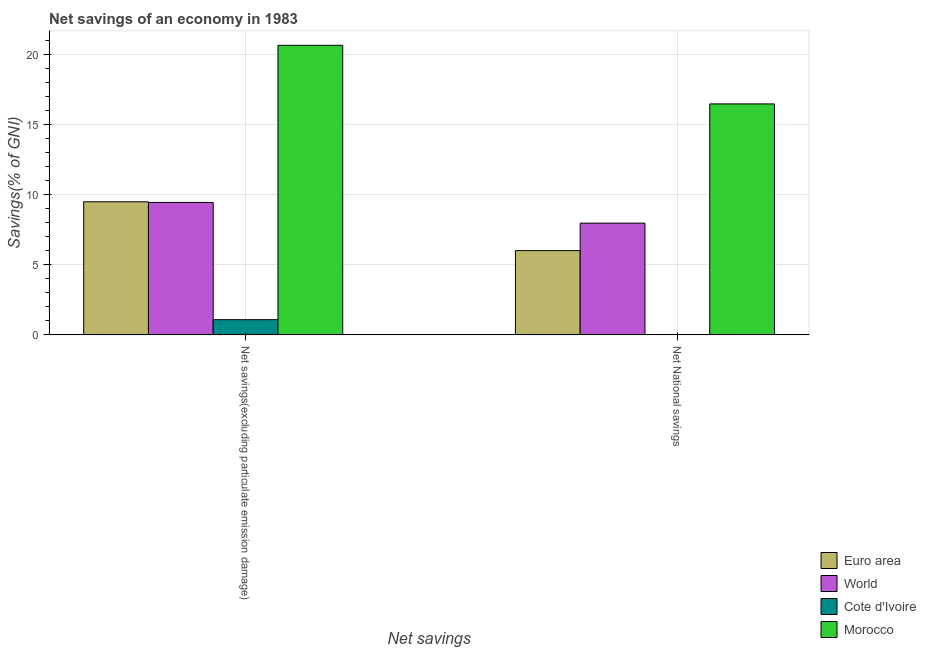How many groups of bars are there?
Make the answer very short. 2. Are the number of bars per tick equal to the number of legend labels?
Provide a succinct answer. No. Are the number of bars on each tick of the X-axis equal?
Your answer should be very brief. No. How many bars are there on the 2nd tick from the left?
Provide a short and direct response. 3. How many bars are there on the 2nd tick from the right?
Provide a short and direct response. 4. What is the label of the 2nd group of bars from the left?
Your answer should be compact. Net National savings. What is the net national savings in Cote d'Ivoire?
Provide a short and direct response. 0. Across all countries, what is the maximum net national savings?
Your response must be concise. 16.48. In which country was the net savings(excluding particulate emission damage) maximum?
Ensure brevity in your answer.  Morocco. What is the total net national savings in the graph?
Provide a short and direct response. 30.47. What is the difference between the net national savings in Morocco and that in Euro area?
Ensure brevity in your answer.  10.47. What is the difference between the net savings(excluding particulate emission damage) in Euro area and the net national savings in World?
Your answer should be very brief. 1.52. What is the average net savings(excluding particulate emission damage) per country?
Offer a very short reply. 10.17. What is the difference between the net savings(excluding particulate emission damage) and net national savings in Morocco?
Your answer should be very brief. 4.18. In how many countries, is the net national savings greater than 2 %?
Your answer should be very brief. 3. What is the ratio of the net national savings in World to that in Euro area?
Give a very brief answer. 1.33. Is the net savings(excluding particulate emission damage) in Cote d'Ivoire less than that in Euro area?
Give a very brief answer. Yes. In how many countries, is the net savings(excluding particulate emission damage) greater than the average net savings(excluding particulate emission damage) taken over all countries?
Your response must be concise. 1. How many bars are there?
Provide a succinct answer. 7. Are all the bars in the graph horizontal?
Your response must be concise. No. Where does the legend appear in the graph?
Provide a short and direct response. Bottom right. How are the legend labels stacked?
Provide a short and direct response. Vertical. What is the title of the graph?
Your answer should be compact. Net savings of an economy in 1983. Does "Tajikistan" appear as one of the legend labels in the graph?
Keep it short and to the point. No. What is the label or title of the X-axis?
Keep it short and to the point. Net savings. What is the label or title of the Y-axis?
Keep it short and to the point. Savings(% of GNI). What is the Savings(% of GNI) in Euro area in Net savings(excluding particulate emission damage)?
Your response must be concise. 9.5. What is the Savings(% of GNI) of World in Net savings(excluding particulate emission damage)?
Ensure brevity in your answer.  9.45. What is the Savings(% of GNI) in Cote d'Ivoire in Net savings(excluding particulate emission damage)?
Offer a terse response. 1.09. What is the Savings(% of GNI) in Morocco in Net savings(excluding particulate emission damage)?
Offer a very short reply. 20.66. What is the Savings(% of GNI) in Euro area in Net National savings?
Provide a short and direct response. 6.01. What is the Savings(% of GNI) of World in Net National savings?
Your response must be concise. 7.97. What is the Savings(% of GNI) of Morocco in Net National savings?
Offer a terse response. 16.48. Across all Net savings, what is the maximum Savings(% of GNI) in Euro area?
Give a very brief answer. 9.5. Across all Net savings, what is the maximum Savings(% of GNI) in World?
Give a very brief answer. 9.45. Across all Net savings, what is the maximum Savings(% of GNI) of Cote d'Ivoire?
Your response must be concise. 1.09. Across all Net savings, what is the maximum Savings(% of GNI) in Morocco?
Make the answer very short. 20.66. Across all Net savings, what is the minimum Savings(% of GNI) of Euro area?
Your answer should be compact. 6.01. Across all Net savings, what is the minimum Savings(% of GNI) of World?
Your response must be concise. 7.97. Across all Net savings, what is the minimum Savings(% of GNI) of Morocco?
Make the answer very short. 16.48. What is the total Savings(% of GNI) in Euro area in the graph?
Provide a succinct answer. 15.51. What is the total Savings(% of GNI) of World in the graph?
Make the answer very short. 17.42. What is the total Savings(% of GNI) of Cote d'Ivoire in the graph?
Ensure brevity in your answer.  1.09. What is the total Savings(% of GNI) of Morocco in the graph?
Provide a short and direct response. 37.15. What is the difference between the Savings(% of GNI) of Euro area in Net savings(excluding particulate emission damage) and that in Net National savings?
Your answer should be very brief. 3.48. What is the difference between the Savings(% of GNI) of World in Net savings(excluding particulate emission damage) and that in Net National savings?
Offer a terse response. 1.48. What is the difference between the Savings(% of GNI) in Morocco in Net savings(excluding particulate emission damage) and that in Net National savings?
Keep it short and to the point. 4.18. What is the difference between the Savings(% of GNI) in Euro area in Net savings(excluding particulate emission damage) and the Savings(% of GNI) in World in Net National savings?
Offer a very short reply. 1.52. What is the difference between the Savings(% of GNI) in Euro area in Net savings(excluding particulate emission damage) and the Savings(% of GNI) in Morocco in Net National savings?
Give a very brief answer. -6.98. What is the difference between the Savings(% of GNI) of World in Net savings(excluding particulate emission damage) and the Savings(% of GNI) of Morocco in Net National savings?
Keep it short and to the point. -7.03. What is the difference between the Savings(% of GNI) of Cote d'Ivoire in Net savings(excluding particulate emission damage) and the Savings(% of GNI) of Morocco in Net National savings?
Your response must be concise. -15.4. What is the average Savings(% of GNI) in Euro area per Net savings?
Provide a succinct answer. 7.76. What is the average Savings(% of GNI) in World per Net savings?
Offer a very short reply. 8.71. What is the average Savings(% of GNI) of Cote d'Ivoire per Net savings?
Your answer should be compact. 0.54. What is the average Savings(% of GNI) of Morocco per Net savings?
Make the answer very short. 18.57. What is the difference between the Savings(% of GNI) in Euro area and Savings(% of GNI) in World in Net savings(excluding particulate emission damage)?
Ensure brevity in your answer.  0.05. What is the difference between the Savings(% of GNI) in Euro area and Savings(% of GNI) in Cote d'Ivoire in Net savings(excluding particulate emission damage)?
Make the answer very short. 8.41. What is the difference between the Savings(% of GNI) of Euro area and Savings(% of GNI) of Morocco in Net savings(excluding particulate emission damage)?
Give a very brief answer. -11.17. What is the difference between the Savings(% of GNI) in World and Savings(% of GNI) in Cote d'Ivoire in Net savings(excluding particulate emission damage)?
Provide a succinct answer. 8.36. What is the difference between the Savings(% of GNI) in World and Savings(% of GNI) in Morocco in Net savings(excluding particulate emission damage)?
Offer a very short reply. -11.21. What is the difference between the Savings(% of GNI) of Cote d'Ivoire and Savings(% of GNI) of Morocco in Net savings(excluding particulate emission damage)?
Your answer should be compact. -19.58. What is the difference between the Savings(% of GNI) in Euro area and Savings(% of GNI) in World in Net National savings?
Provide a succinct answer. -1.96. What is the difference between the Savings(% of GNI) in Euro area and Savings(% of GNI) in Morocco in Net National savings?
Give a very brief answer. -10.47. What is the difference between the Savings(% of GNI) in World and Savings(% of GNI) in Morocco in Net National savings?
Provide a short and direct response. -8.51. What is the ratio of the Savings(% of GNI) in Euro area in Net savings(excluding particulate emission damage) to that in Net National savings?
Provide a succinct answer. 1.58. What is the ratio of the Savings(% of GNI) of World in Net savings(excluding particulate emission damage) to that in Net National savings?
Make the answer very short. 1.19. What is the ratio of the Savings(% of GNI) of Morocco in Net savings(excluding particulate emission damage) to that in Net National savings?
Your answer should be very brief. 1.25. What is the difference between the highest and the second highest Savings(% of GNI) of Euro area?
Make the answer very short. 3.48. What is the difference between the highest and the second highest Savings(% of GNI) in World?
Offer a very short reply. 1.48. What is the difference between the highest and the second highest Savings(% of GNI) in Morocco?
Offer a very short reply. 4.18. What is the difference between the highest and the lowest Savings(% of GNI) in Euro area?
Your answer should be very brief. 3.48. What is the difference between the highest and the lowest Savings(% of GNI) of World?
Your answer should be very brief. 1.48. What is the difference between the highest and the lowest Savings(% of GNI) of Cote d'Ivoire?
Provide a short and direct response. 1.09. What is the difference between the highest and the lowest Savings(% of GNI) of Morocco?
Offer a terse response. 4.18. 